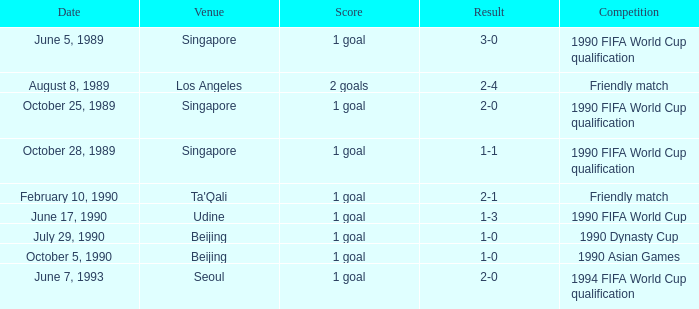What was the score of the match with a 3-0 result? 1 goal. 